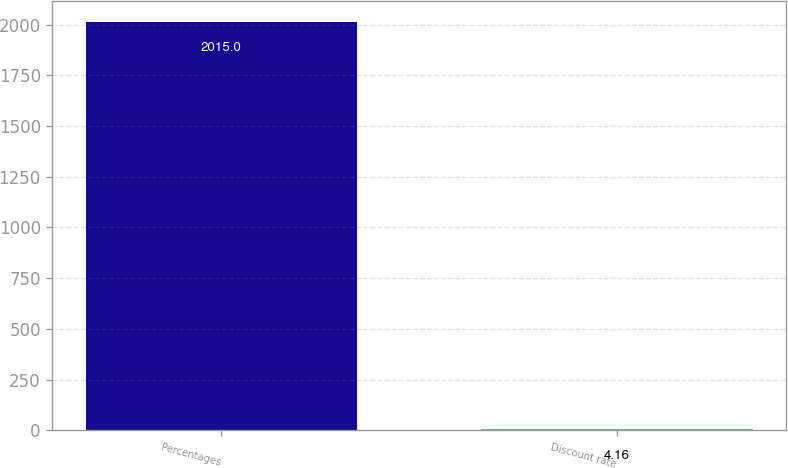Convert chart. <chart><loc_0><loc_0><loc_500><loc_500><bar_chart><fcel>Percentages<fcel>Discount rate<nl><fcel>2015<fcel>4.16<nl></chart> 